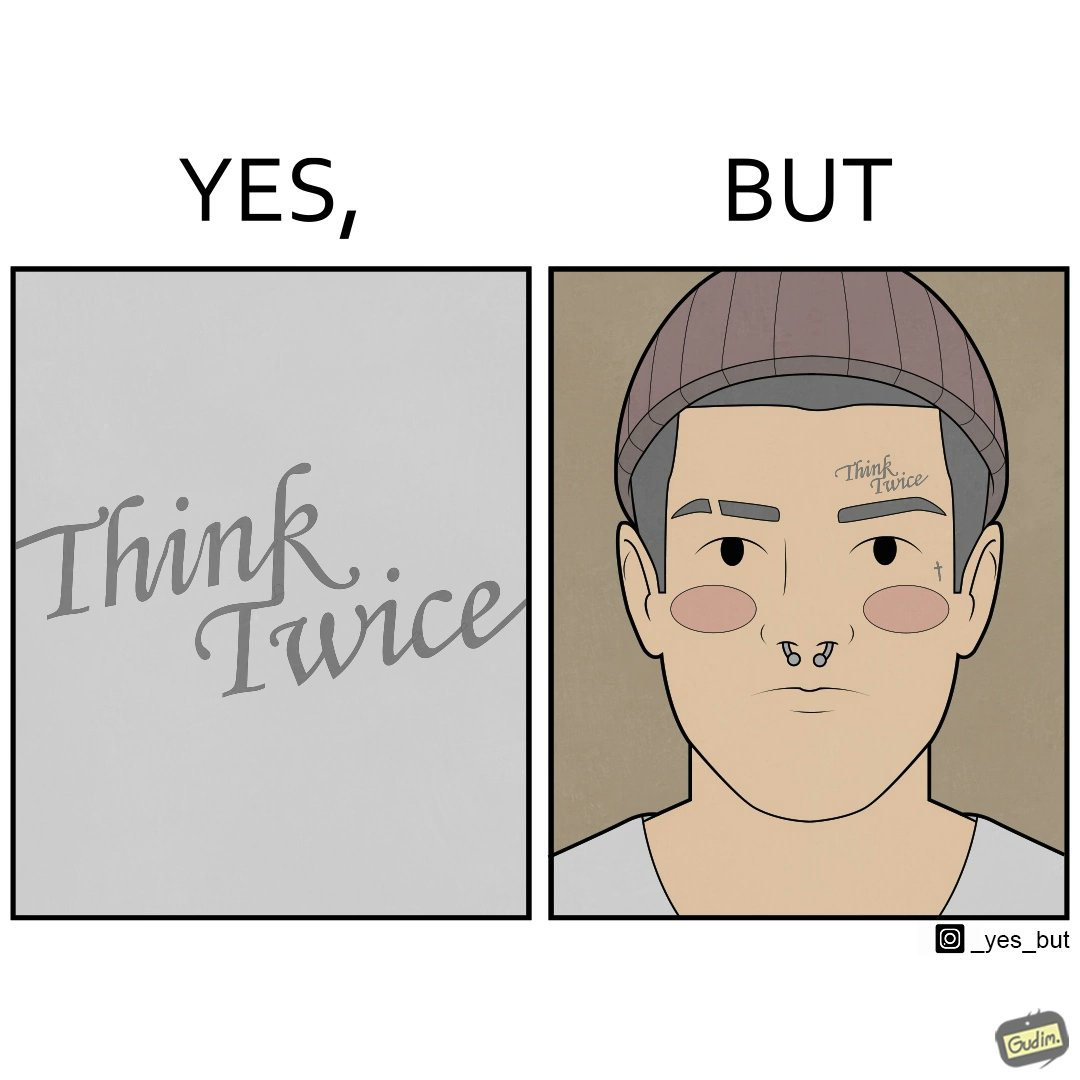Describe the content of this image. The image is funny because even thought the tattoo on the face of the man says "think twice", the man did not think twice before getting the tattoo on his forehead. 